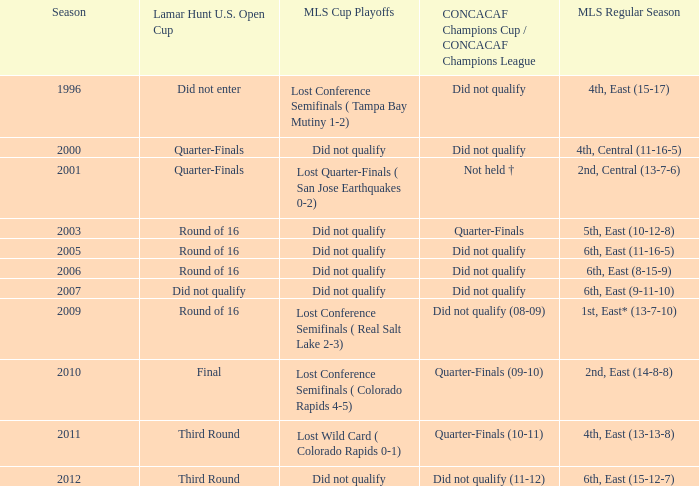How many mls cup playoffs where there for the mls regular season is 1st, east* (13-7-10)? 1.0. 